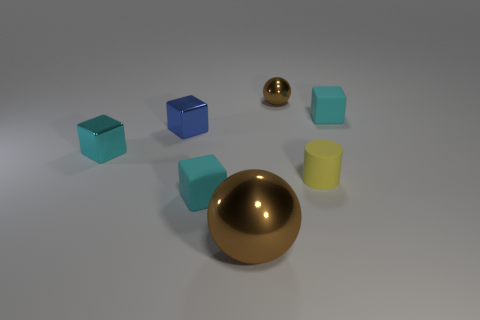Are there any balls of the same color as the big thing?
Your response must be concise. Yes. How many cubes are either tiny purple things or large brown objects?
Keep it short and to the point. 0. There is another metallic object that is the same color as the big thing; what is its size?
Provide a succinct answer. Small. Are there fewer tiny blue metal cubes that are in front of the yellow object than metallic cylinders?
Offer a terse response. No. What is the color of the metallic object that is to the right of the tiny blue block and in front of the tiny brown ball?
Keep it short and to the point. Brown. What number of other objects are the same shape as the large metallic object?
Give a very brief answer. 1. Are there fewer tiny blue blocks that are on the left side of the blue block than small cyan objects right of the yellow matte object?
Ensure brevity in your answer.  Yes. Is the tiny ball made of the same material as the thing that is on the left side of the small blue cube?
Your answer should be compact. Yes. Is the number of cyan rubber objects greater than the number of large brown shiny spheres?
Ensure brevity in your answer.  Yes. There is a tiny cyan thing that is right of the big shiny object in front of the shiny sphere behind the large brown object; what is its shape?
Give a very brief answer. Cube. 